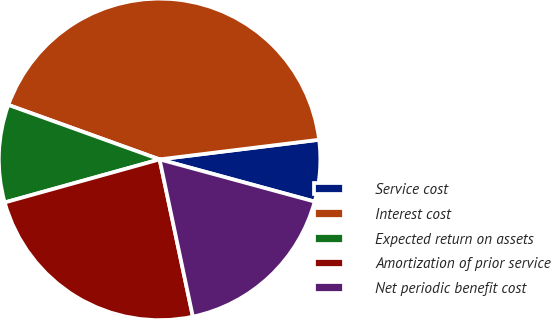Convert chart to OTSL. <chart><loc_0><loc_0><loc_500><loc_500><pie_chart><fcel>Service cost<fcel>Interest cost<fcel>Expected return on assets<fcel>Amortization of prior service<fcel>Net periodic benefit cost<nl><fcel>6.18%<fcel>42.55%<fcel>9.82%<fcel>24.0%<fcel>17.45%<nl></chart> 